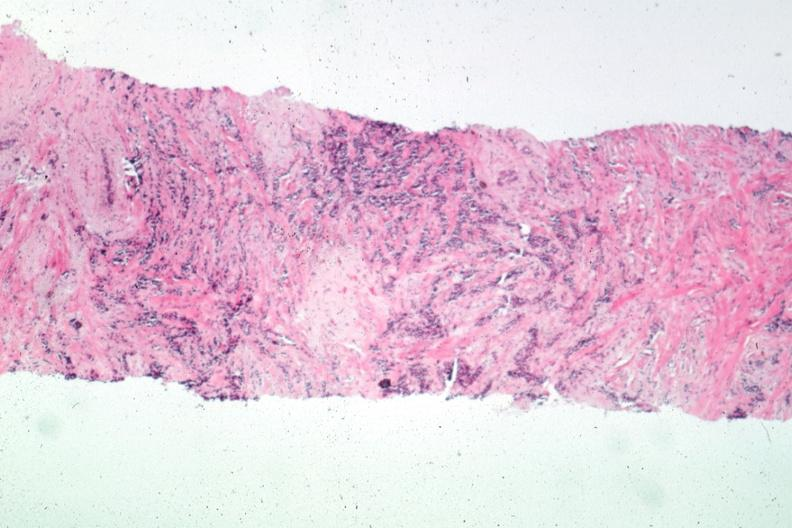what is present?
Answer the question using a single word or phrase. Breast 